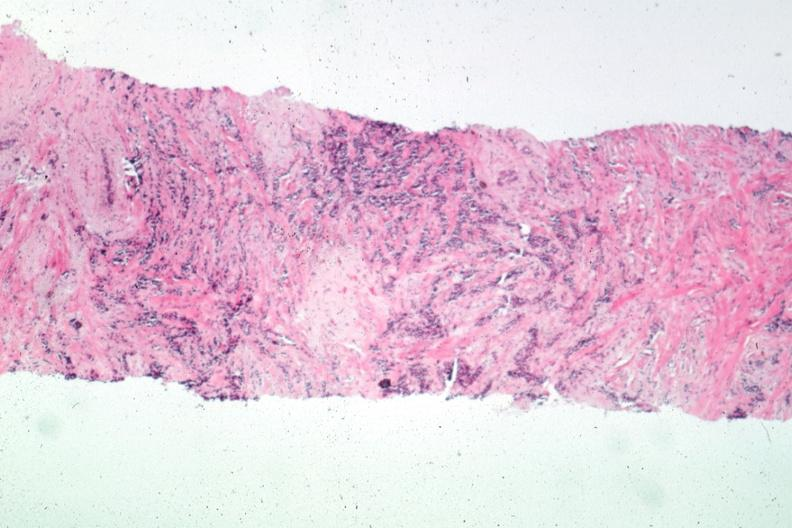what is present?
Answer the question using a single word or phrase. Breast 